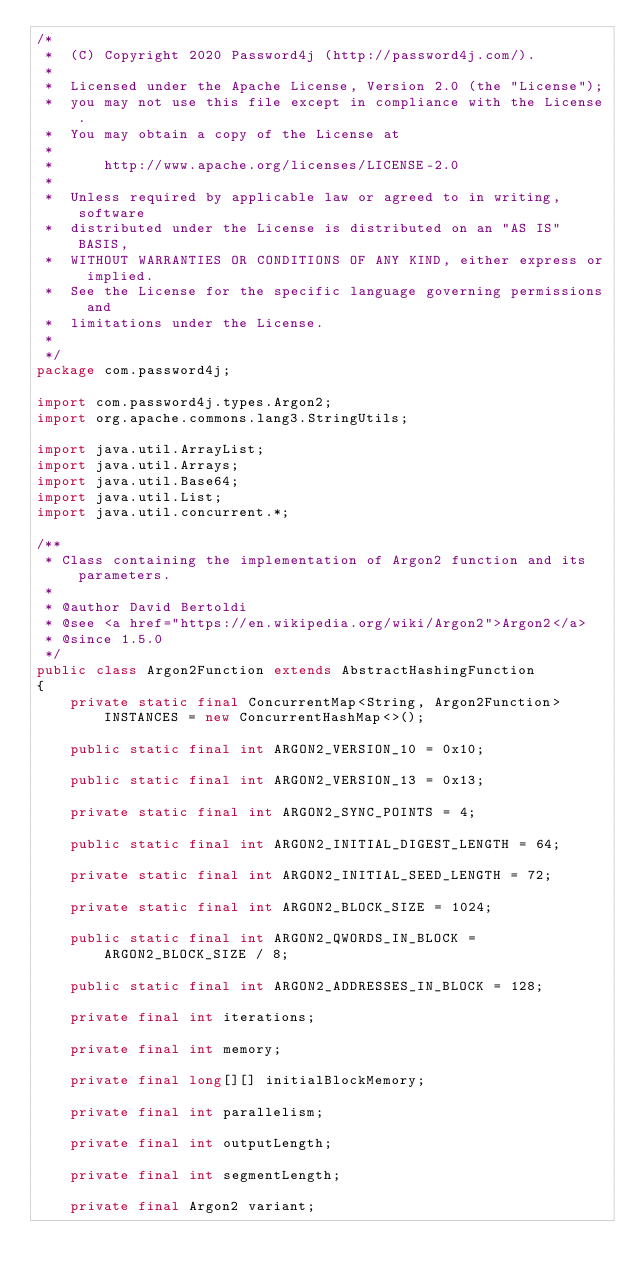<code> <loc_0><loc_0><loc_500><loc_500><_Java_>/*
 *  (C) Copyright 2020 Password4j (http://password4j.com/).
 *
 *  Licensed under the Apache License, Version 2.0 (the "License");
 *  you may not use this file except in compliance with the License.
 *  You may obtain a copy of the License at
 *
 *      http://www.apache.org/licenses/LICENSE-2.0
 *
 *  Unless required by applicable law or agreed to in writing, software
 *  distributed under the License is distributed on an "AS IS" BASIS,
 *  WITHOUT WARRANTIES OR CONDITIONS OF ANY KIND, either express or implied.
 *  See the License for the specific language governing permissions and
 *  limitations under the License.
 *
 */
package com.password4j;

import com.password4j.types.Argon2;
import org.apache.commons.lang3.StringUtils;

import java.util.ArrayList;
import java.util.Arrays;
import java.util.Base64;
import java.util.List;
import java.util.concurrent.*;

/**
 * Class containing the implementation of Argon2 function and its parameters.
 *
 * @author David Bertoldi
 * @see <a href="https://en.wikipedia.org/wiki/Argon2">Argon2</a>
 * @since 1.5.0
 */
public class Argon2Function extends AbstractHashingFunction
{
    private static final ConcurrentMap<String, Argon2Function> INSTANCES = new ConcurrentHashMap<>();

    public static final int ARGON2_VERSION_10 = 0x10;

    public static final int ARGON2_VERSION_13 = 0x13;

    private static final int ARGON2_SYNC_POINTS = 4;

    public static final int ARGON2_INITIAL_DIGEST_LENGTH = 64;

    private static final int ARGON2_INITIAL_SEED_LENGTH = 72;

    private static final int ARGON2_BLOCK_SIZE = 1024;

    public static final int ARGON2_QWORDS_IN_BLOCK = ARGON2_BLOCK_SIZE / 8;

    public static final int ARGON2_ADDRESSES_IN_BLOCK = 128;

    private final int iterations;

    private final int memory;

    private final long[][] initialBlockMemory;

    private final int parallelism;

    private final int outputLength;

    private final int segmentLength;

    private final Argon2 variant;
</code> 